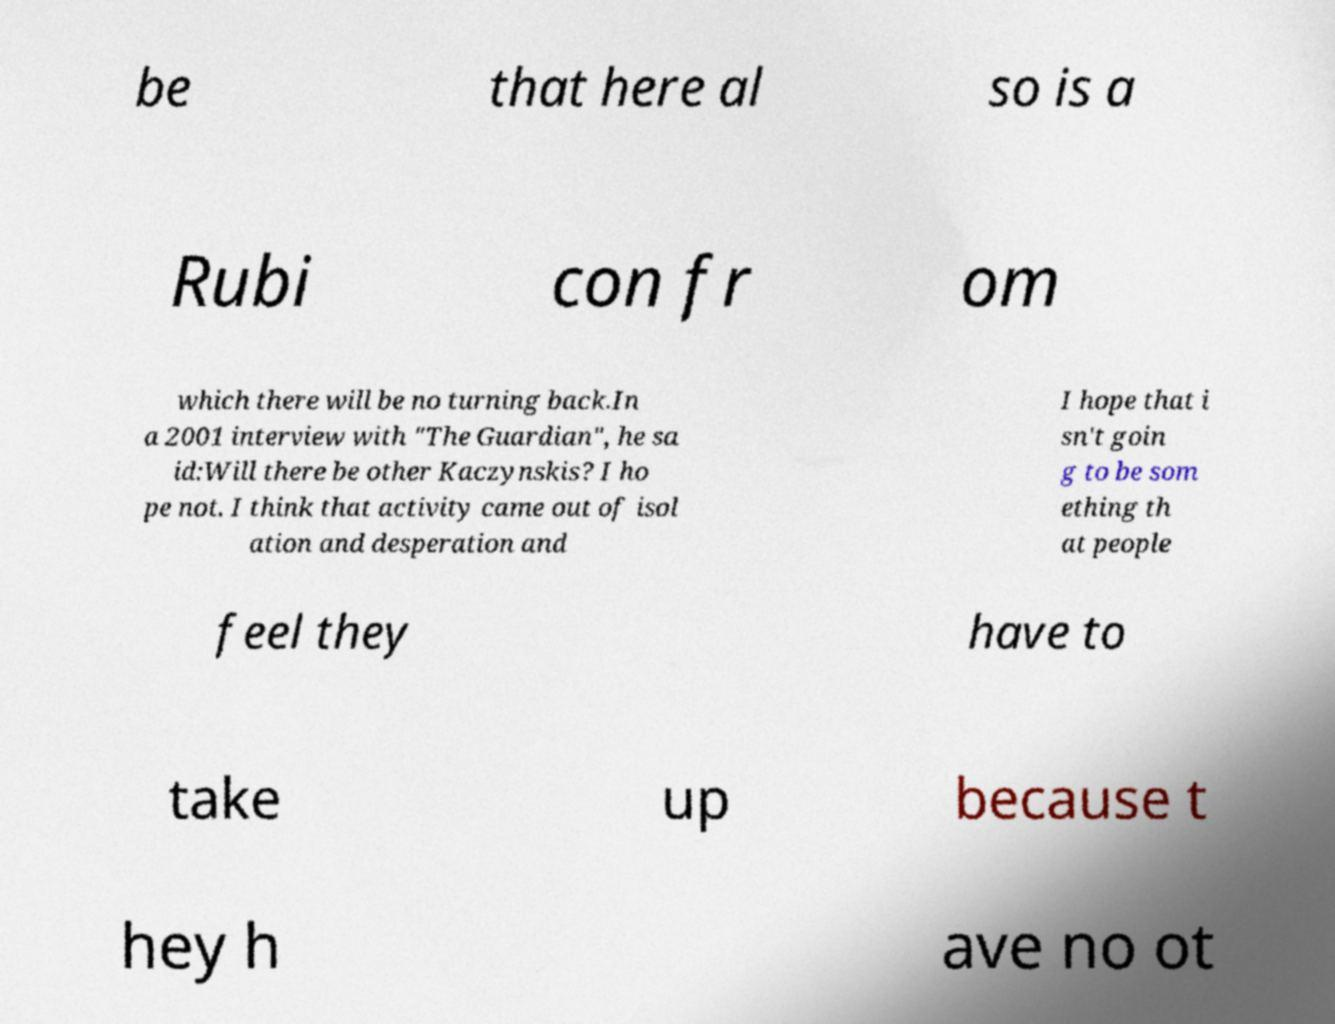There's text embedded in this image that I need extracted. Can you transcribe it verbatim? be that here al so is a Rubi con fr om which there will be no turning back.In a 2001 interview with "The Guardian", he sa id:Will there be other Kaczynskis? I ho pe not. I think that activity came out of isol ation and desperation and I hope that i sn't goin g to be som ething th at people feel they have to take up because t hey h ave no ot 